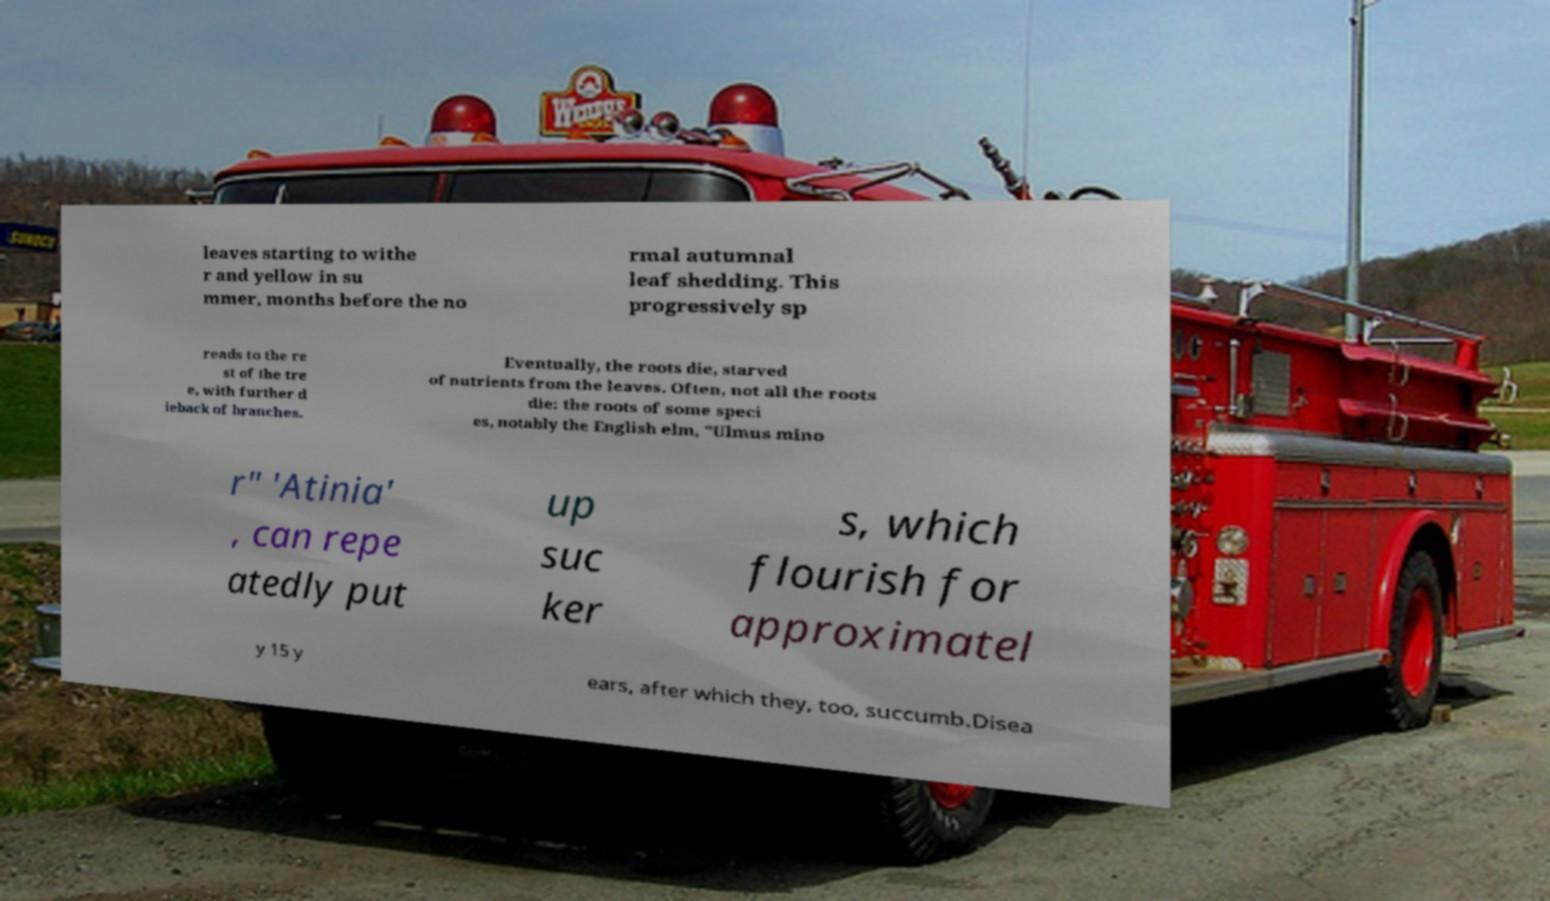Could you assist in decoding the text presented in this image and type it out clearly? leaves starting to withe r and yellow in su mmer, months before the no rmal autumnal leaf shedding. This progressively sp reads to the re st of the tre e, with further d ieback of branches. Eventually, the roots die, starved of nutrients from the leaves. Often, not all the roots die: the roots of some speci es, notably the English elm, "Ulmus mino r" 'Atinia' , can repe atedly put up suc ker s, which flourish for approximatel y 15 y ears, after which they, too, succumb.Disea 